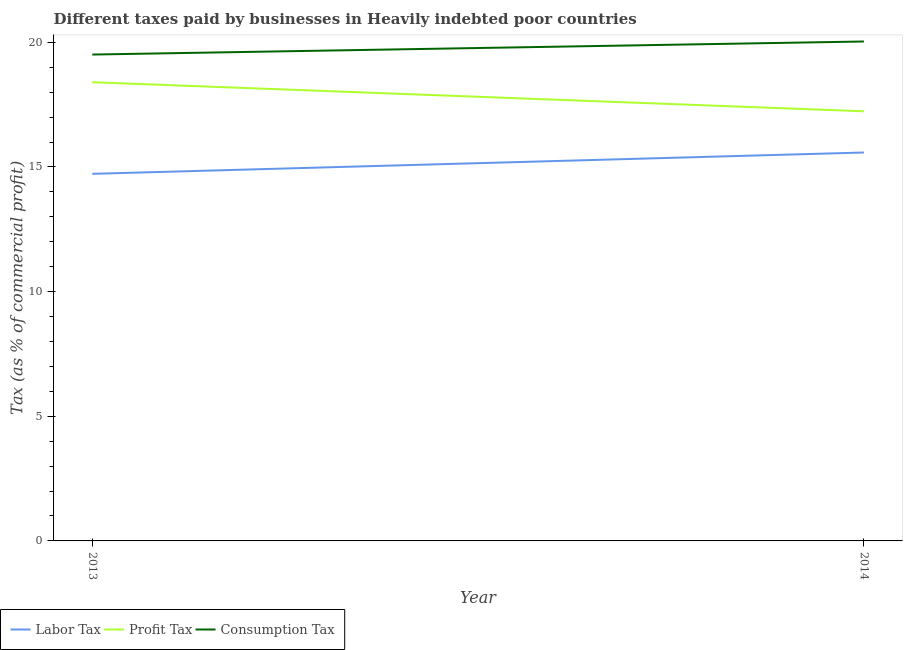How many different coloured lines are there?
Provide a succinct answer. 3. Does the line corresponding to percentage of profit tax intersect with the line corresponding to percentage of labor tax?
Offer a terse response. No. What is the percentage of consumption tax in 2014?
Ensure brevity in your answer.  20.03. Across all years, what is the maximum percentage of consumption tax?
Offer a very short reply. 20.03. Across all years, what is the minimum percentage of profit tax?
Provide a short and direct response. 17.23. In which year was the percentage of profit tax maximum?
Keep it short and to the point. 2013. What is the total percentage of labor tax in the graph?
Ensure brevity in your answer.  30.3. What is the difference between the percentage of labor tax in 2013 and that in 2014?
Offer a terse response. -0.86. What is the difference between the percentage of profit tax in 2013 and the percentage of labor tax in 2014?
Provide a succinct answer. 2.82. What is the average percentage of profit tax per year?
Make the answer very short. 17.81. In the year 2014, what is the difference between the percentage of consumption tax and percentage of profit tax?
Give a very brief answer. 2.8. In how many years, is the percentage of consumption tax greater than 14 %?
Give a very brief answer. 2. What is the ratio of the percentage of labor tax in 2013 to that in 2014?
Offer a very short reply. 0.95. Is the percentage of labor tax in 2013 less than that in 2014?
Your answer should be very brief. Yes. In how many years, is the percentage of labor tax greater than the average percentage of labor tax taken over all years?
Make the answer very short. 1. Is it the case that in every year, the sum of the percentage of labor tax and percentage of profit tax is greater than the percentage of consumption tax?
Provide a succinct answer. Yes. Does the percentage of profit tax monotonically increase over the years?
Ensure brevity in your answer.  No. What is the difference between two consecutive major ticks on the Y-axis?
Provide a short and direct response. 5. Does the graph contain any zero values?
Make the answer very short. No. Where does the legend appear in the graph?
Your response must be concise. Bottom left. How are the legend labels stacked?
Provide a succinct answer. Horizontal. What is the title of the graph?
Ensure brevity in your answer.  Different taxes paid by businesses in Heavily indebted poor countries. Does "Ages 15-64" appear as one of the legend labels in the graph?
Provide a succinct answer. No. What is the label or title of the X-axis?
Provide a succinct answer. Year. What is the label or title of the Y-axis?
Your response must be concise. Tax (as % of commercial profit). What is the Tax (as % of commercial profit) of Labor Tax in 2013?
Ensure brevity in your answer.  14.72. What is the Tax (as % of commercial profit) in Profit Tax in 2013?
Ensure brevity in your answer.  18.4. What is the Tax (as % of commercial profit) of Consumption Tax in 2013?
Your response must be concise. 19.51. What is the Tax (as % of commercial profit) in Labor Tax in 2014?
Provide a succinct answer. 15.58. What is the Tax (as % of commercial profit) of Profit Tax in 2014?
Provide a short and direct response. 17.23. What is the Tax (as % of commercial profit) of Consumption Tax in 2014?
Provide a short and direct response. 20.03. Across all years, what is the maximum Tax (as % of commercial profit) of Labor Tax?
Provide a short and direct response. 15.58. Across all years, what is the maximum Tax (as % of commercial profit) in Profit Tax?
Ensure brevity in your answer.  18.4. Across all years, what is the maximum Tax (as % of commercial profit) of Consumption Tax?
Offer a very short reply. 20.03. Across all years, what is the minimum Tax (as % of commercial profit) of Labor Tax?
Provide a short and direct response. 14.72. Across all years, what is the minimum Tax (as % of commercial profit) in Profit Tax?
Your response must be concise. 17.23. Across all years, what is the minimum Tax (as % of commercial profit) of Consumption Tax?
Make the answer very short. 19.51. What is the total Tax (as % of commercial profit) of Labor Tax in the graph?
Your answer should be very brief. 30.3. What is the total Tax (as % of commercial profit) of Profit Tax in the graph?
Your answer should be compact. 35.63. What is the total Tax (as % of commercial profit) of Consumption Tax in the graph?
Keep it short and to the point. 39.54. What is the difference between the Tax (as % of commercial profit) in Labor Tax in 2013 and that in 2014?
Keep it short and to the point. -0.86. What is the difference between the Tax (as % of commercial profit) of Profit Tax in 2013 and that in 2014?
Your answer should be very brief. 1.17. What is the difference between the Tax (as % of commercial profit) of Consumption Tax in 2013 and that in 2014?
Offer a terse response. -0.52. What is the difference between the Tax (as % of commercial profit) of Labor Tax in 2013 and the Tax (as % of commercial profit) of Profit Tax in 2014?
Your answer should be compact. -2.51. What is the difference between the Tax (as % of commercial profit) of Labor Tax in 2013 and the Tax (as % of commercial profit) of Consumption Tax in 2014?
Your answer should be very brief. -5.31. What is the difference between the Tax (as % of commercial profit) of Profit Tax in 2013 and the Tax (as % of commercial profit) of Consumption Tax in 2014?
Offer a terse response. -1.63. What is the average Tax (as % of commercial profit) of Labor Tax per year?
Provide a succinct answer. 15.15. What is the average Tax (as % of commercial profit) of Profit Tax per year?
Offer a terse response. 17.81. What is the average Tax (as % of commercial profit) of Consumption Tax per year?
Your answer should be very brief. 19.77. In the year 2013, what is the difference between the Tax (as % of commercial profit) in Labor Tax and Tax (as % of commercial profit) in Profit Tax?
Provide a succinct answer. -3.67. In the year 2013, what is the difference between the Tax (as % of commercial profit) in Labor Tax and Tax (as % of commercial profit) in Consumption Tax?
Provide a short and direct response. -4.78. In the year 2013, what is the difference between the Tax (as % of commercial profit) in Profit Tax and Tax (as % of commercial profit) in Consumption Tax?
Offer a terse response. -1.11. In the year 2014, what is the difference between the Tax (as % of commercial profit) in Labor Tax and Tax (as % of commercial profit) in Profit Tax?
Provide a short and direct response. -1.65. In the year 2014, what is the difference between the Tax (as % of commercial profit) in Labor Tax and Tax (as % of commercial profit) in Consumption Tax?
Your response must be concise. -4.45. In the year 2014, what is the difference between the Tax (as % of commercial profit) in Profit Tax and Tax (as % of commercial profit) in Consumption Tax?
Keep it short and to the point. -2.8. What is the ratio of the Tax (as % of commercial profit) of Labor Tax in 2013 to that in 2014?
Offer a terse response. 0.95. What is the ratio of the Tax (as % of commercial profit) in Profit Tax in 2013 to that in 2014?
Make the answer very short. 1.07. What is the ratio of the Tax (as % of commercial profit) in Consumption Tax in 2013 to that in 2014?
Your answer should be very brief. 0.97. What is the difference between the highest and the second highest Tax (as % of commercial profit) in Labor Tax?
Offer a very short reply. 0.86. What is the difference between the highest and the second highest Tax (as % of commercial profit) in Profit Tax?
Provide a succinct answer. 1.17. What is the difference between the highest and the second highest Tax (as % of commercial profit) in Consumption Tax?
Keep it short and to the point. 0.52. What is the difference between the highest and the lowest Tax (as % of commercial profit) in Labor Tax?
Make the answer very short. 0.86. What is the difference between the highest and the lowest Tax (as % of commercial profit) of Profit Tax?
Offer a terse response. 1.17. What is the difference between the highest and the lowest Tax (as % of commercial profit) in Consumption Tax?
Provide a short and direct response. 0.52. 